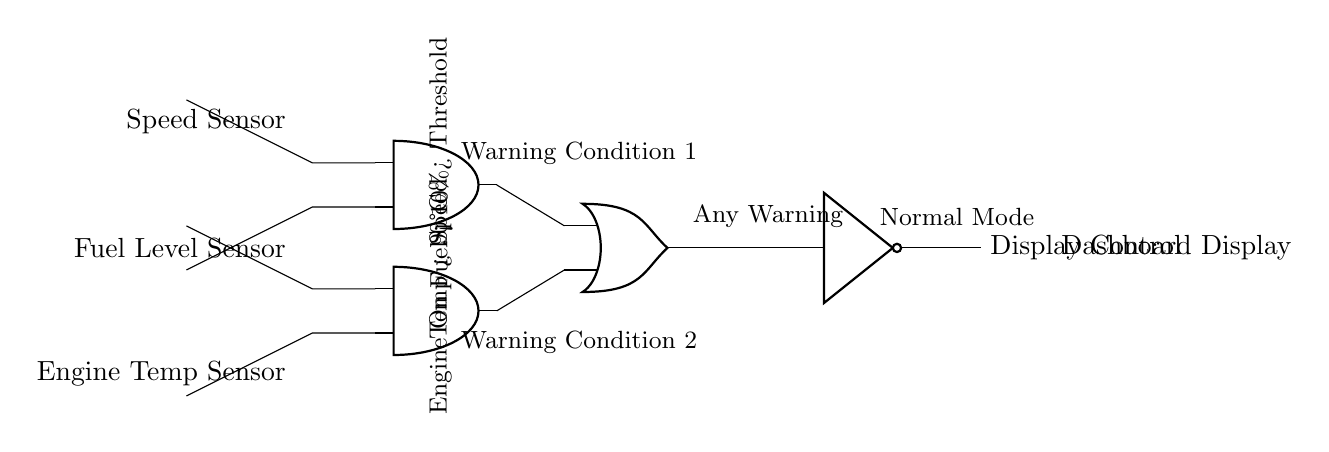What outputs control the dashboard display? The dashboard display is controlled by the output of the NOT gate, which receives input from the OR gate. The OR gate combines inputs from two AND gates, which indicate warning conditions from the speed sensor, fuel level sensor, and engine temperature sensor.
Answer: Display Control How many AND gates are present in the circuit? The circuit includes two AND gates, labeled as AND1 and AND2. These gates process signals from the speed sensor and fuel level sensor to determine specific warning conditions.
Answer: Two What is the condition for Warning Condition 1? Warning Condition 1 occurs when the speed is greater than a specified threshold and the fuel level is below 10%. This is determined by the first AND gate output.
Answer: Speed greater than threshold and fuel less than 10 percent What does the NOT gate do in this circuit? The NOT gate inverts the output of the OR gate, changing a warning signal into a normal mode signal for the dashboard display. When the OR gate's output is high due to any warning presence, the NOT gate ensures that the final output reflects a normal state when all conditions are okay.
Answer: It inverts the OR gate's output Under what specific conditions is Warning Condition 2 activated? Warning Condition 2 is activated when warning conditions from both the speed sensor and the fuel sensor are met, combined through the second AND gate. This condition checks if the engine is on and if either specified threshold for the speed or fuel is crossed to confirm an engine issue.
Answer: Engine on, Speed greater than threshold and fuel less than 10 percent What does the output of the OR gate signify? The output of the OR gate signifies any warning condition from the inputs of the two AND gates. If either AND gate produces a high signal, it indicates that at least one critical vehicle parameter has exceeded the set thresholds.
Answer: Any warning Which sensors feed input directly into the AND gates? The sensors providing direct input to the AND gates are the speed sensor and the fuel level sensor. The outputs of these sensors determine the high and low states of the inputs to the AND gates for processing warning conditions.
Answer: Speed and fuel level sensors 